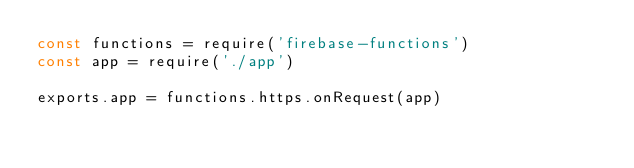Convert code to text. <code><loc_0><loc_0><loc_500><loc_500><_JavaScript_>const functions = require('firebase-functions')
const app = require('./app')

exports.app = functions.https.onRequest(app)
</code> 